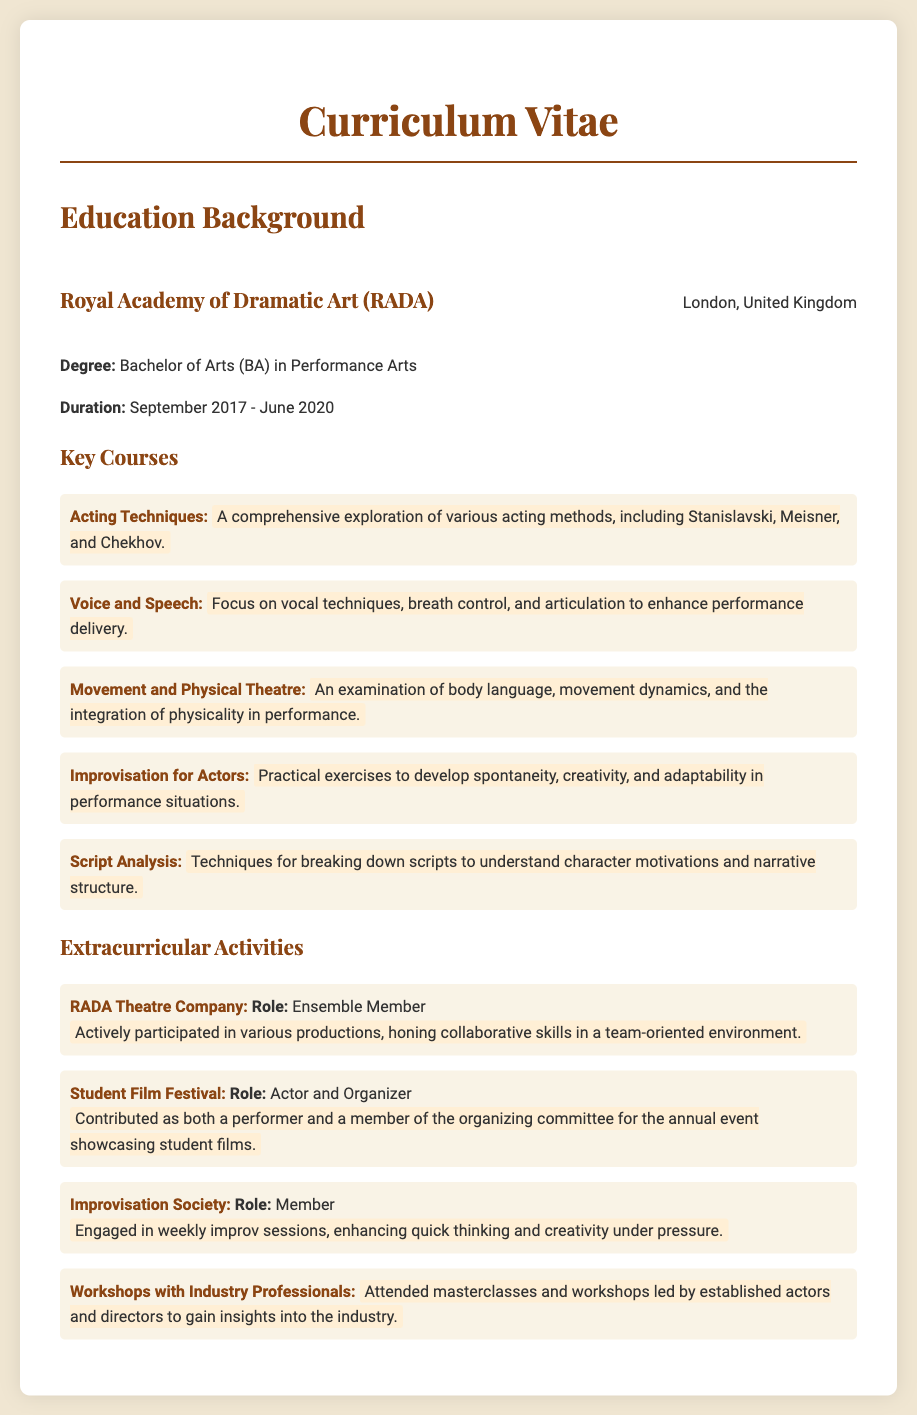What is the name of the drama school attended? The document states that the actor attended the Royal Academy of Dramatic Art (RADA).
Answer: Royal Academy of Dramatic Art (RADA) What degree was obtained? The document mentions that the actor earned a Bachelor of Arts (BA) in Performance Arts.
Answer: Bachelor of Arts (BA) in Performance Arts What was the duration of the studies? According to the document, the duration of the studies was from September 2017 to June 2020.
Answer: September 2017 - June 2020 Which acting technique is included in the key courses? The document lists "Acting Techniques," which covers various acting methods.
Answer: Acting Techniques How many extracurricular activities are listed? The document details four extracurricular activities that contributed to the actor's development.
Answer: Four What is the role of the actor in the RADA Theatre Company? The document indicates that the actor served as an Ensemble Member in the RADA Theatre Company.
Answer: Ensemble Member Which course focuses on voice techniques? The course "Voice and Speech" aims to enhance vocal techniques and delivery performance.
Answer: Voice and Speech What is one skill enhanced through the Improvisation Society? The document states that the actor enhanced quick thinking and creativity through their participation.
Answer: Quick thinking What type of events does the Student Film Festival showcase? It showcases student films as detailed in the description of the actor's involvement.
Answer: Student films 